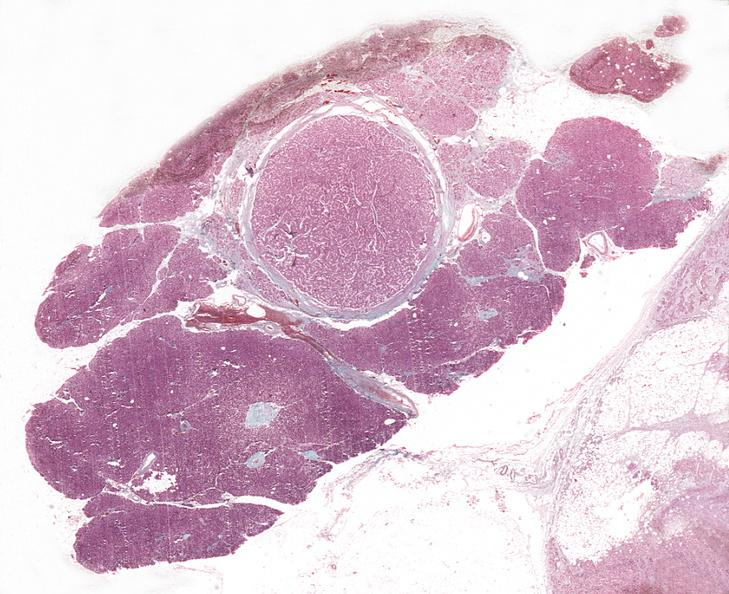does medial aspect show islet cell adenoma, non-functional?
Answer the question using a single word or phrase. No 